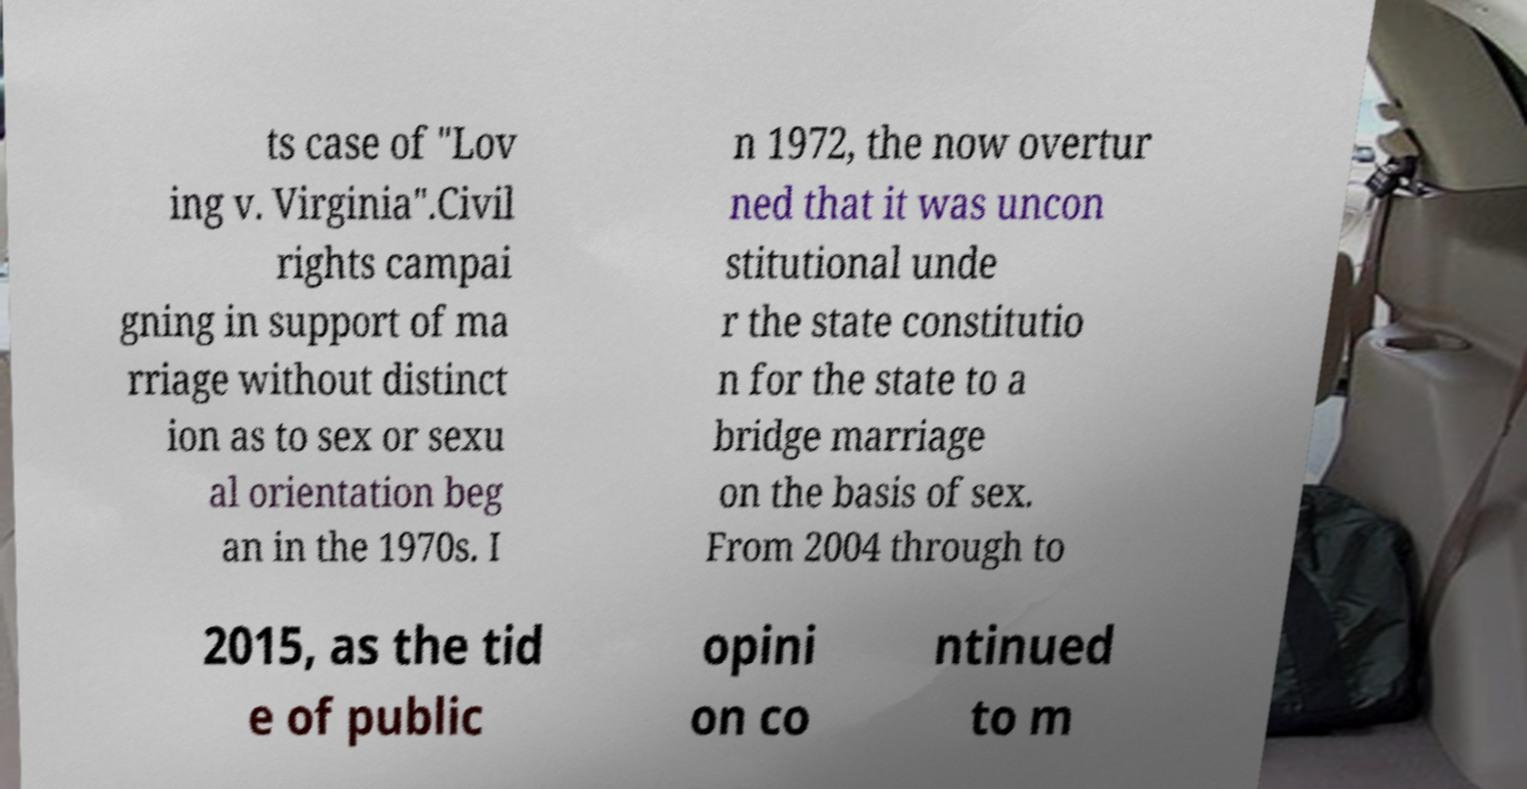Can you accurately transcribe the text from the provided image for me? ts case of "Lov ing v. Virginia".Civil rights campai gning in support of ma rriage without distinct ion as to sex or sexu al orientation beg an in the 1970s. I n 1972, the now overtur ned that it was uncon stitutional unde r the state constitutio n for the state to a bridge marriage on the basis of sex. From 2004 through to 2015, as the tid e of public opini on co ntinued to m 